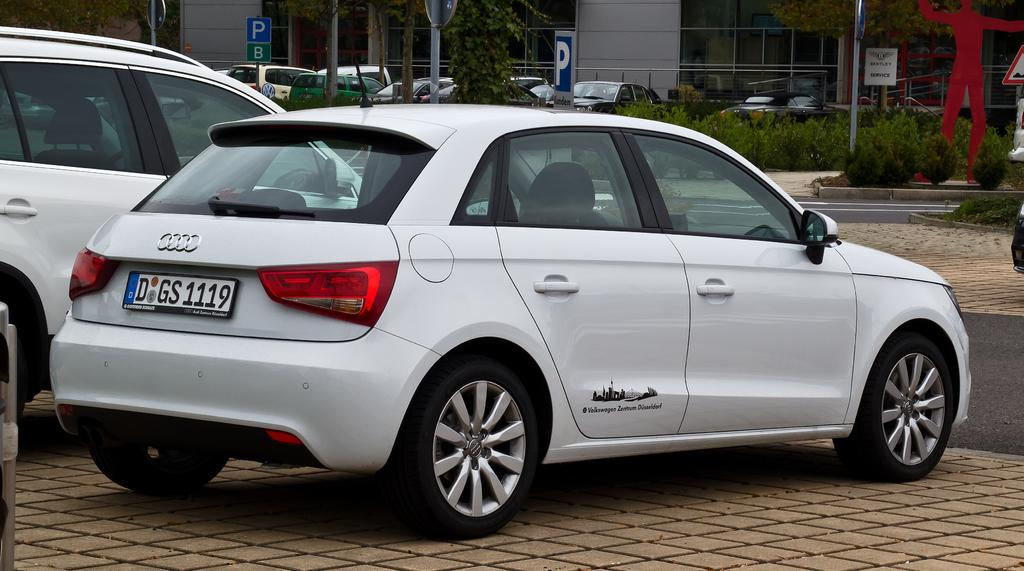What types of objects can be seen in the image? There are vehicles, boards, poles, plants, walls, and glass windows in the image. Can you describe the vehicles in the image? The provided facts do not specify the type or appearance of the vehicles. What are the boards used for in the image? The purpose of the boards in the image is not mentioned in the provided facts. What kind of plants are present in the image? The provided facts do not specify the type or appearance of the plants. What are the walls made of in the image? The material of the walls is not mentioned in the provided facts. What type of rings can be seen on the side of the drug in the image? There is no mention of rings, drugs, or a side in the provided facts; these elements are not present in the image. 